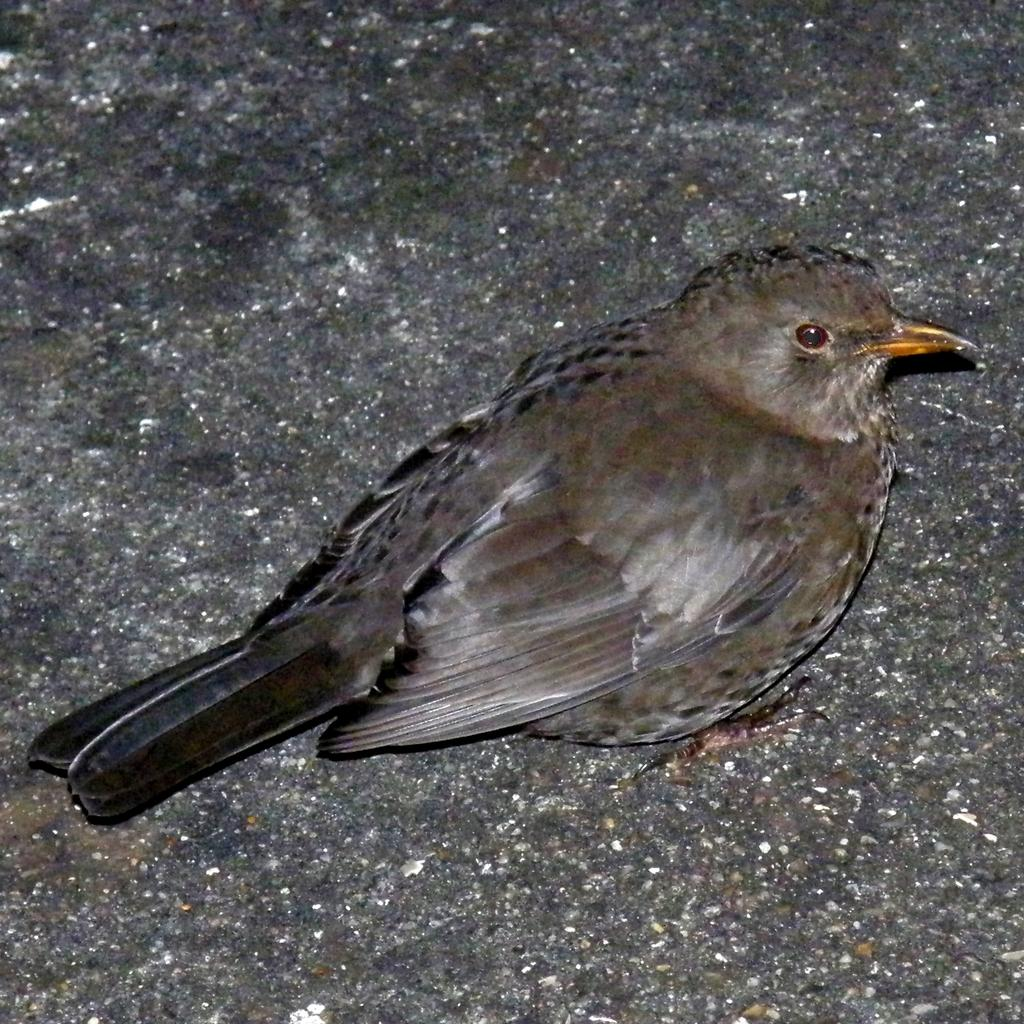What type of animal is in the image? There is a bird in the image. Where is the bird located in the image? The bird is standing on the floor. What type of work do the fairies perform in the image? There are no fairies present in the image, so it is not possible to answer that question. 